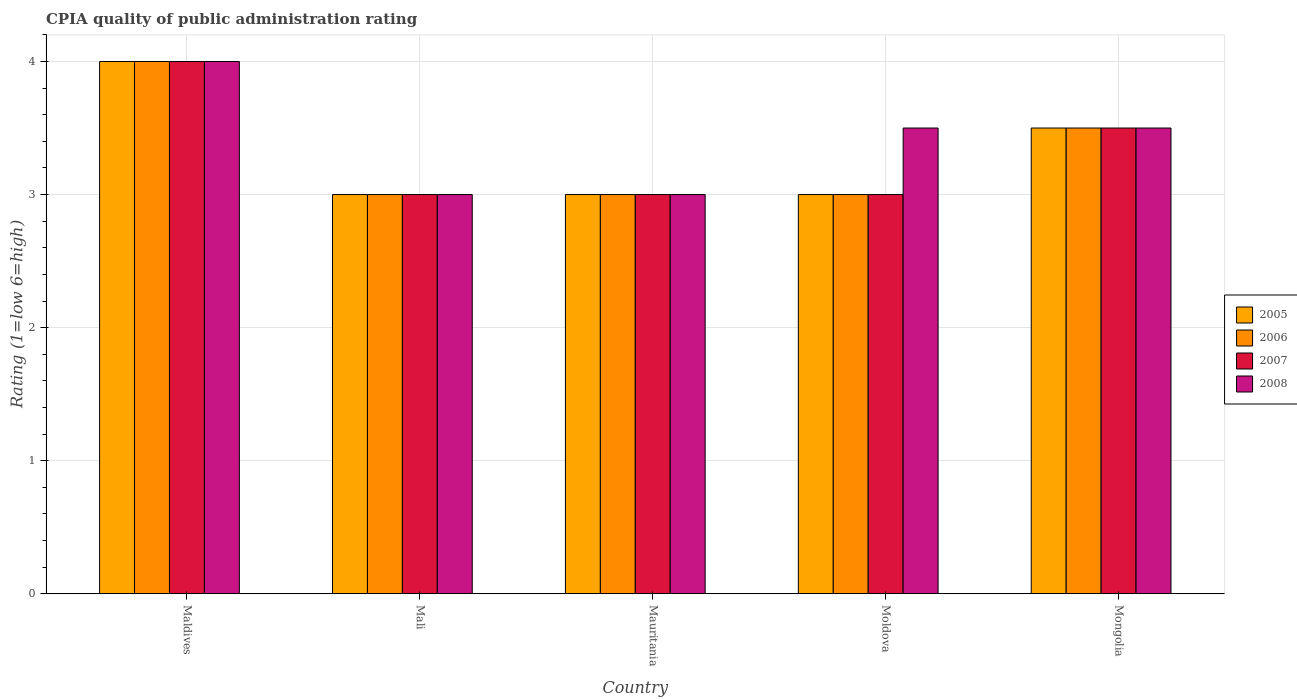How many different coloured bars are there?
Your answer should be very brief. 4. What is the label of the 4th group of bars from the left?
Your response must be concise. Moldova. What is the CPIA rating in 2007 in Mali?
Provide a short and direct response. 3. Across all countries, what is the maximum CPIA rating in 2005?
Provide a short and direct response. 4. In which country was the CPIA rating in 2007 maximum?
Ensure brevity in your answer.  Maldives. In which country was the CPIA rating in 2008 minimum?
Ensure brevity in your answer.  Mali. What is the difference between the CPIA rating in 2005 in Moldova and that in Mongolia?
Ensure brevity in your answer.  -0.5. What is the difference between the CPIA rating in 2006 in Moldova and the CPIA rating in 2008 in Mali?
Offer a terse response. 0. In how many countries, is the CPIA rating in 2006 greater than 3.8?
Give a very brief answer. 1. What is the ratio of the CPIA rating in 2007 in Maldives to that in Mongolia?
Provide a succinct answer. 1.14. Is the CPIA rating in 2005 in Mali less than that in Moldova?
Keep it short and to the point. No. What is the difference between the highest and the second highest CPIA rating in 2007?
Provide a short and direct response. -0.5. What is the difference between the highest and the lowest CPIA rating in 2008?
Provide a short and direct response. 1. Is the sum of the CPIA rating in 2006 in Mauritania and Moldova greater than the maximum CPIA rating in 2007 across all countries?
Offer a very short reply. Yes. What does the 1st bar from the left in Mongolia represents?
Your answer should be very brief. 2005. Is it the case that in every country, the sum of the CPIA rating in 2008 and CPIA rating in 2007 is greater than the CPIA rating in 2006?
Your answer should be very brief. Yes. Are all the bars in the graph horizontal?
Offer a very short reply. No. How many countries are there in the graph?
Your answer should be compact. 5. What is the difference between two consecutive major ticks on the Y-axis?
Your response must be concise. 1. Are the values on the major ticks of Y-axis written in scientific E-notation?
Your answer should be very brief. No. Does the graph contain any zero values?
Make the answer very short. No. Where does the legend appear in the graph?
Your answer should be compact. Center right. How many legend labels are there?
Your answer should be very brief. 4. What is the title of the graph?
Ensure brevity in your answer.  CPIA quality of public administration rating. What is the label or title of the Y-axis?
Make the answer very short. Rating (1=low 6=high). What is the Rating (1=low 6=high) of 2006 in Maldives?
Offer a very short reply. 4. What is the Rating (1=low 6=high) in 2007 in Maldives?
Offer a very short reply. 4. What is the Rating (1=low 6=high) of 2006 in Mali?
Make the answer very short. 3. What is the Rating (1=low 6=high) of 2006 in Mauritania?
Keep it short and to the point. 3. What is the Rating (1=low 6=high) of 2007 in Mauritania?
Give a very brief answer. 3. What is the Rating (1=low 6=high) of 2006 in Moldova?
Keep it short and to the point. 3. What is the Rating (1=low 6=high) of 2007 in Moldova?
Keep it short and to the point. 3. What is the Rating (1=low 6=high) in 2008 in Moldova?
Keep it short and to the point. 3.5. What is the Rating (1=low 6=high) in 2005 in Mongolia?
Your response must be concise. 3.5. What is the Rating (1=low 6=high) in 2006 in Mongolia?
Make the answer very short. 3.5. What is the Rating (1=low 6=high) of 2007 in Mongolia?
Your response must be concise. 3.5. Across all countries, what is the maximum Rating (1=low 6=high) in 2008?
Provide a succinct answer. 4. Across all countries, what is the minimum Rating (1=low 6=high) of 2005?
Provide a short and direct response. 3. Across all countries, what is the minimum Rating (1=low 6=high) of 2008?
Your answer should be compact. 3. What is the total Rating (1=low 6=high) in 2006 in the graph?
Provide a short and direct response. 16.5. What is the difference between the Rating (1=low 6=high) in 2007 in Maldives and that in Mali?
Provide a short and direct response. 1. What is the difference between the Rating (1=low 6=high) of 2008 in Maldives and that in Mali?
Ensure brevity in your answer.  1. What is the difference between the Rating (1=low 6=high) in 2007 in Maldives and that in Mauritania?
Your answer should be compact. 1. What is the difference between the Rating (1=low 6=high) of 2008 in Maldives and that in Mauritania?
Make the answer very short. 1. What is the difference between the Rating (1=low 6=high) in 2006 in Maldives and that in Moldova?
Give a very brief answer. 1. What is the difference between the Rating (1=low 6=high) in 2005 in Maldives and that in Mongolia?
Offer a terse response. 0.5. What is the difference between the Rating (1=low 6=high) in 2006 in Maldives and that in Mongolia?
Provide a succinct answer. 0.5. What is the difference between the Rating (1=low 6=high) of 2007 in Maldives and that in Mongolia?
Make the answer very short. 0.5. What is the difference between the Rating (1=low 6=high) in 2005 in Mali and that in Mauritania?
Keep it short and to the point. 0. What is the difference between the Rating (1=low 6=high) in 2005 in Mali and that in Moldova?
Your answer should be compact. 0. What is the difference between the Rating (1=low 6=high) of 2006 in Mali and that in Moldova?
Your response must be concise. 0. What is the difference between the Rating (1=low 6=high) in 2007 in Mali and that in Moldova?
Your answer should be compact. 0. What is the difference between the Rating (1=low 6=high) of 2008 in Mali and that in Moldova?
Provide a short and direct response. -0.5. What is the difference between the Rating (1=low 6=high) of 2008 in Mali and that in Mongolia?
Your answer should be compact. -0.5. What is the difference between the Rating (1=low 6=high) of 2005 in Mauritania and that in Moldova?
Your answer should be compact. 0. What is the difference between the Rating (1=low 6=high) of 2006 in Mauritania and that in Moldova?
Provide a succinct answer. 0. What is the difference between the Rating (1=low 6=high) of 2008 in Mauritania and that in Moldova?
Ensure brevity in your answer.  -0.5. What is the difference between the Rating (1=low 6=high) of 2006 in Mauritania and that in Mongolia?
Your response must be concise. -0.5. What is the difference between the Rating (1=low 6=high) in 2007 in Mauritania and that in Mongolia?
Your response must be concise. -0.5. What is the difference between the Rating (1=low 6=high) of 2008 in Mauritania and that in Mongolia?
Offer a terse response. -0.5. What is the difference between the Rating (1=low 6=high) of 2006 in Moldova and that in Mongolia?
Your response must be concise. -0.5. What is the difference between the Rating (1=low 6=high) in 2007 in Moldova and that in Mongolia?
Your response must be concise. -0.5. What is the difference between the Rating (1=low 6=high) in 2005 in Maldives and the Rating (1=low 6=high) in 2006 in Mali?
Provide a short and direct response. 1. What is the difference between the Rating (1=low 6=high) in 2005 in Maldives and the Rating (1=low 6=high) in 2007 in Mali?
Provide a short and direct response. 1. What is the difference between the Rating (1=low 6=high) in 2005 in Maldives and the Rating (1=low 6=high) in 2008 in Mali?
Keep it short and to the point. 1. What is the difference between the Rating (1=low 6=high) in 2006 in Maldives and the Rating (1=low 6=high) in 2008 in Mali?
Provide a short and direct response. 1. What is the difference between the Rating (1=low 6=high) in 2007 in Maldives and the Rating (1=low 6=high) in 2008 in Mali?
Provide a short and direct response. 1. What is the difference between the Rating (1=low 6=high) in 2005 in Maldives and the Rating (1=low 6=high) in 2006 in Mauritania?
Provide a short and direct response. 1. What is the difference between the Rating (1=low 6=high) of 2007 in Maldives and the Rating (1=low 6=high) of 2008 in Mauritania?
Your answer should be compact. 1. What is the difference between the Rating (1=low 6=high) of 2005 in Maldives and the Rating (1=low 6=high) of 2007 in Moldova?
Offer a very short reply. 1. What is the difference between the Rating (1=low 6=high) of 2005 in Maldives and the Rating (1=low 6=high) of 2008 in Moldova?
Provide a succinct answer. 0.5. What is the difference between the Rating (1=low 6=high) of 2006 in Maldives and the Rating (1=low 6=high) of 2008 in Moldova?
Offer a terse response. 0.5. What is the difference between the Rating (1=low 6=high) in 2005 in Maldives and the Rating (1=low 6=high) in 2007 in Mongolia?
Your response must be concise. 0.5. What is the difference between the Rating (1=low 6=high) of 2006 in Maldives and the Rating (1=low 6=high) of 2007 in Mongolia?
Your answer should be very brief. 0.5. What is the difference between the Rating (1=low 6=high) in 2006 in Maldives and the Rating (1=low 6=high) in 2008 in Mongolia?
Ensure brevity in your answer.  0.5. What is the difference between the Rating (1=low 6=high) in 2007 in Maldives and the Rating (1=low 6=high) in 2008 in Mongolia?
Keep it short and to the point. 0.5. What is the difference between the Rating (1=low 6=high) in 2005 in Mali and the Rating (1=low 6=high) in 2006 in Moldova?
Provide a succinct answer. 0. What is the difference between the Rating (1=low 6=high) in 2006 in Mali and the Rating (1=low 6=high) in 2008 in Moldova?
Offer a very short reply. -0.5. What is the difference between the Rating (1=low 6=high) of 2005 in Mali and the Rating (1=low 6=high) of 2008 in Mongolia?
Offer a terse response. -0.5. What is the difference between the Rating (1=low 6=high) of 2006 in Mali and the Rating (1=low 6=high) of 2008 in Mongolia?
Offer a very short reply. -0.5. What is the difference between the Rating (1=low 6=high) of 2005 in Mauritania and the Rating (1=low 6=high) of 2008 in Moldova?
Offer a very short reply. -0.5. What is the difference between the Rating (1=low 6=high) in 2006 in Mauritania and the Rating (1=low 6=high) in 2007 in Moldova?
Provide a short and direct response. 0. What is the difference between the Rating (1=low 6=high) in 2007 in Mauritania and the Rating (1=low 6=high) in 2008 in Moldova?
Offer a very short reply. -0.5. What is the difference between the Rating (1=low 6=high) of 2005 in Mauritania and the Rating (1=low 6=high) of 2007 in Mongolia?
Offer a very short reply. -0.5. What is the difference between the Rating (1=low 6=high) of 2005 in Moldova and the Rating (1=low 6=high) of 2006 in Mongolia?
Offer a very short reply. -0.5. What is the average Rating (1=low 6=high) in 2006 per country?
Provide a short and direct response. 3.3. What is the average Rating (1=low 6=high) in 2008 per country?
Your response must be concise. 3.4. What is the difference between the Rating (1=low 6=high) in 2005 and Rating (1=low 6=high) in 2008 in Maldives?
Your response must be concise. 0. What is the difference between the Rating (1=low 6=high) in 2006 and Rating (1=low 6=high) in 2007 in Maldives?
Give a very brief answer. 0. What is the difference between the Rating (1=low 6=high) of 2006 and Rating (1=low 6=high) of 2008 in Maldives?
Provide a succinct answer. 0. What is the difference between the Rating (1=low 6=high) of 2007 and Rating (1=low 6=high) of 2008 in Maldives?
Give a very brief answer. 0. What is the difference between the Rating (1=low 6=high) of 2006 and Rating (1=low 6=high) of 2007 in Mali?
Give a very brief answer. 0. What is the difference between the Rating (1=low 6=high) in 2006 and Rating (1=low 6=high) in 2008 in Mali?
Your answer should be very brief. 0. What is the difference between the Rating (1=low 6=high) of 2007 and Rating (1=low 6=high) of 2008 in Mali?
Keep it short and to the point. 0. What is the difference between the Rating (1=low 6=high) of 2005 and Rating (1=low 6=high) of 2006 in Mauritania?
Give a very brief answer. 0. What is the difference between the Rating (1=low 6=high) of 2005 and Rating (1=low 6=high) of 2007 in Mauritania?
Offer a terse response. 0. What is the difference between the Rating (1=low 6=high) of 2006 and Rating (1=low 6=high) of 2007 in Mauritania?
Give a very brief answer. 0. What is the difference between the Rating (1=low 6=high) of 2006 and Rating (1=low 6=high) of 2008 in Mauritania?
Your answer should be compact. 0. What is the difference between the Rating (1=low 6=high) in 2007 and Rating (1=low 6=high) in 2008 in Mauritania?
Offer a very short reply. 0. What is the difference between the Rating (1=low 6=high) in 2006 and Rating (1=low 6=high) in 2007 in Moldova?
Offer a very short reply. 0. What is the difference between the Rating (1=low 6=high) of 2006 and Rating (1=low 6=high) of 2008 in Moldova?
Keep it short and to the point. -0.5. What is the difference between the Rating (1=low 6=high) in 2005 and Rating (1=low 6=high) in 2006 in Mongolia?
Give a very brief answer. 0. What is the difference between the Rating (1=low 6=high) of 2005 and Rating (1=low 6=high) of 2007 in Mongolia?
Ensure brevity in your answer.  0. What is the difference between the Rating (1=low 6=high) of 2006 and Rating (1=low 6=high) of 2007 in Mongolia?
Your answer should be very brief. 0. What is the difference between the Rating (1=low 6=high) in 2006 and Rating (1=low 6=high) in 2008 in Mongolia?
Give a very brief answer. 0. What is the ratio of the Rating (1=low 6=high) in 2005 in Maldives to that in Mali?
Provide a succinct answer. 1.33. What is the ratio of the Rating (1=low 6=high) in 2007 in Maldives to that in Mali?
Offer a very short reply. 1.33. What is the ratio of the Rating (1=low 6=high) of 2006 in Maldives to that in Mauritania?
Ensure brevity in your answer.  1.33. What is the ratio of the Rating (1=low 6=high) of 2005 in Maldives to that in Moldova?
Keep it short and to the point. 1.33. What is the ratio of the Rating (1=low 6=high) in 2006 in Maldives to that in Moldova?
Your answer should be very brief. 1.33. What is the ratio of the Rating (1=low 6=high) of 2007 in Maldives to that in Moldova?
Your answer should be compact. 1.33. What is the ratio of the Rating (1=low 6=high) in 2008 in Maldives to that in Moldova?
Provide a succinct answer. 1.14. What is the ratio of the Rating (1=low 6=high) of 2005 in Maldives to that in Mongolia?
Offer a very short reply. 1.14. What is the ratio of the Rating (1=low 6=high) of 2007 in Maldives to that in Mongolia?
Your answer should be very brief. 1.14. What is the ratio of the Rating (1=low 6=high) in 2007 in Mali to that in Mauritania?
Your response must be concise. 1. What is the ratio of the Rating (1=low 6=high) in 2007 in Mali to that in Moldova?
Keep it short and to the point. 1. What is the ratio of the Rating (1=low 6=high) in 2006 in Mali to that in Mongolia?
Make the answer very short. 0.86. What is the ratio of the Rating (1=low 6=high) in 2008 in Mali to that in Mongolia?
Provide a short and direct response. 0.86. What is the ratio of the Rating (1=low 6=high) in 2005 in Mauritania to that in Moldova?
Give a very brief answer. 1. What is the ratio of the Rating (1=low 6=high) in 2007 in Mauritania to that in Moldova?
Offer a terse response. 1. What is the ratio of the Rating (1=low 6=high) of 2008 in Mauritania to that in Moldova?
Your response must be concise. 0.86. What is the ratio of the Rating (1=low 6=high) in 2005 in Mauritania to that in Mongolia?
Your answer should be very brief. 0.86. What is the ratio of the Rating (1=low 6=high) of 2006 in Mauritania to that in Mongolia?
Give a very brief answer. 0.86. What is the ratio of the Rating (1=low 6=high) in 2007 in Mauritania to that in Mongolia?
Your answer should be very brief. 0.86. What is the ratio of the Rating (1=low 6=high) in 2005 in Moldova to that in Mongolia?
Provide a succinct answer. 0.86. What is the ratio of the Rating (1=low 6=high) in 2007 in Moldova to that in Mongolia?
Your answer should be very brief. 0.86. What is the ratio of the Rating (1=low 6=high) of 2008 in Moldova to that in Mongolia?
Provide a short and direct response. 1. What is the difference between the highest and the second highest Rating (1=low 6=high) of 2005?
Offer a very short reply. 0.5. What is the difference between the highest and the second highest Rating (1=low 6=high) in 2006?
Your answer should be compact. 0.5. What is the difference between the highest and the lowest Rating (1=low 6=high) of 2006?
Offer a terse response. 1. What is the difference between the highest and the lowest Rating (1=low 6=high) in 2007?
Provide a short and direct response. 1. 